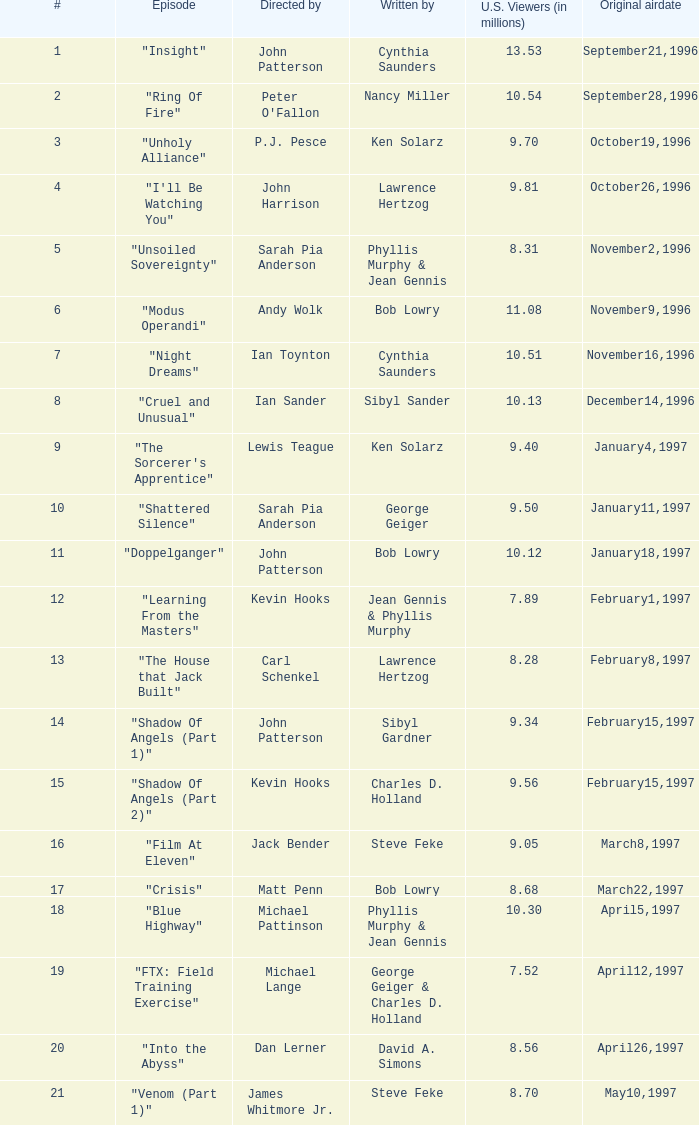Who composed the episode attracting Lawrence Hertzog. 